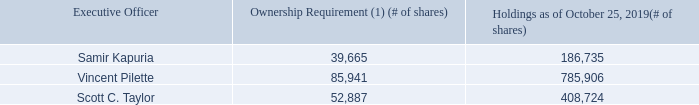Stock Ownership Requirements
We believe that in order to align the interests of our executive officers with those of our stockholders, our executive officers should have a financial stake in our Company. We have maintained stock ownership requirements for our executive officers since October 2005. For FY19, our executive officers were required to hold the following minimum number of shares:
• CEO: 6x base salary; • CFO, COO and President: 3x base salary; and • Executive Vice Presidents: 2x base salary.
Stock options and unvested RSUs and PRUs do not count toward stock ownership requirements.
The executive officer is required to acquire and thereafter maintain the stock ownership required within four years of becoming an executive officer of NortonLifeLock (or four years following the adoption date of these revised guidelines). During the four-year transitional period, each executive officer must retain at least 50% of all net (after-tax) equity grants until the required stock ownership level has been met.
As of October 25, 2019, Messrs. Kapuria, Pilette and Taylor reached the stated ownership requirements for FY19. Transitioning or former executive officers and non-executive officers are not included in the table below. See the table below for individual ownership levels relative to the executive’s ownership requirement.
(1) Based on the closing price for a share of our common stock of $22.69 on October 25, 2019.
What is the ownership requirement based on? The closing price for a share of our common stock of $22.69 on october 25, 2019. What is the minimum number of shares needed by a CEO? 6x base salary. What is the minimum number of shares needed by a Executive Vice President? 2x base salary. What is the total summed ownership requirement for the Executive officers? 39,665+85,941+52,887
Answer: 178493. What is the value of Samir Kapuria's shares as of October 25, 2019? 186,735*22.69
Answer: 4237017.15. What is the value of Vincent Pilette's shares as of October 25, 2019? 785,906*22.69
Answer: 17832207.14. 